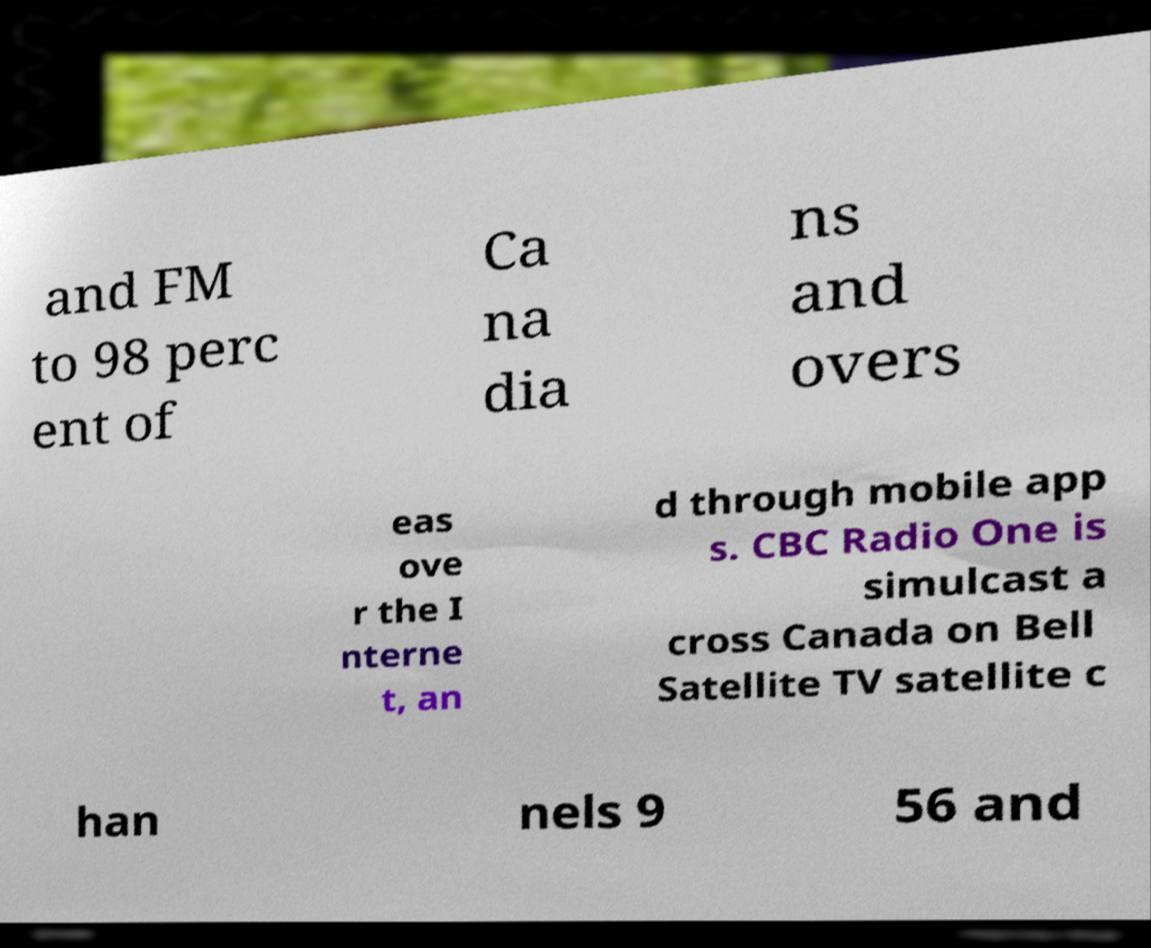What messages or text are displayed in this image? I need them in a readable, typed format. and FM to 98 perc ent of Ca na dia ns and overs eas ove r the I nterne t, an d through mobile app s. CBC Radio One is simulcast a cross Canada on Bell Satellite TV satellite c han nels 9 56 and 